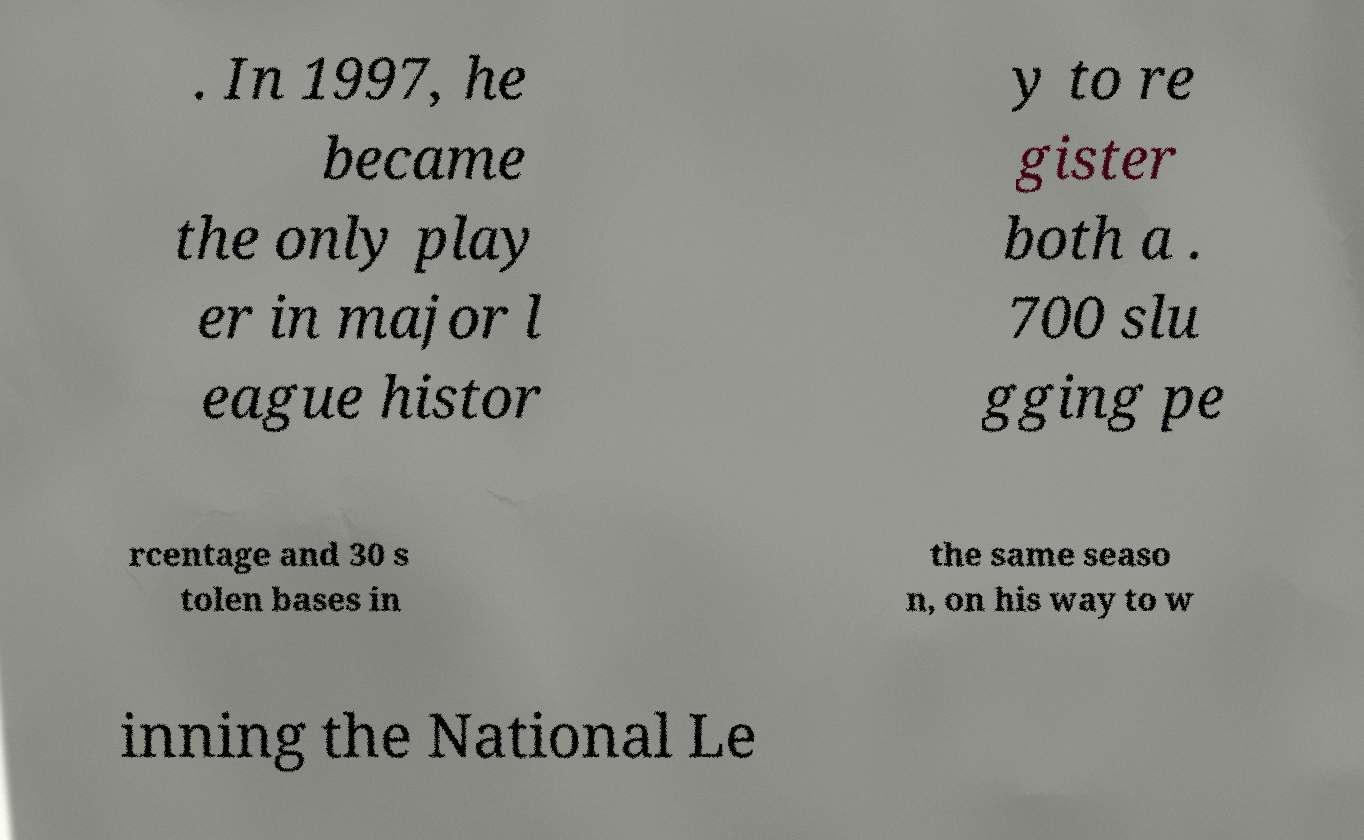I need the written content from this picture converted into text. Can you do that? . In 1997, he became the only play er in major l eague histor y to re gister both a . 700 slu gging pe rcentage and 30 s tolen bases in the same seaso n, on his way to w inning the National Le 